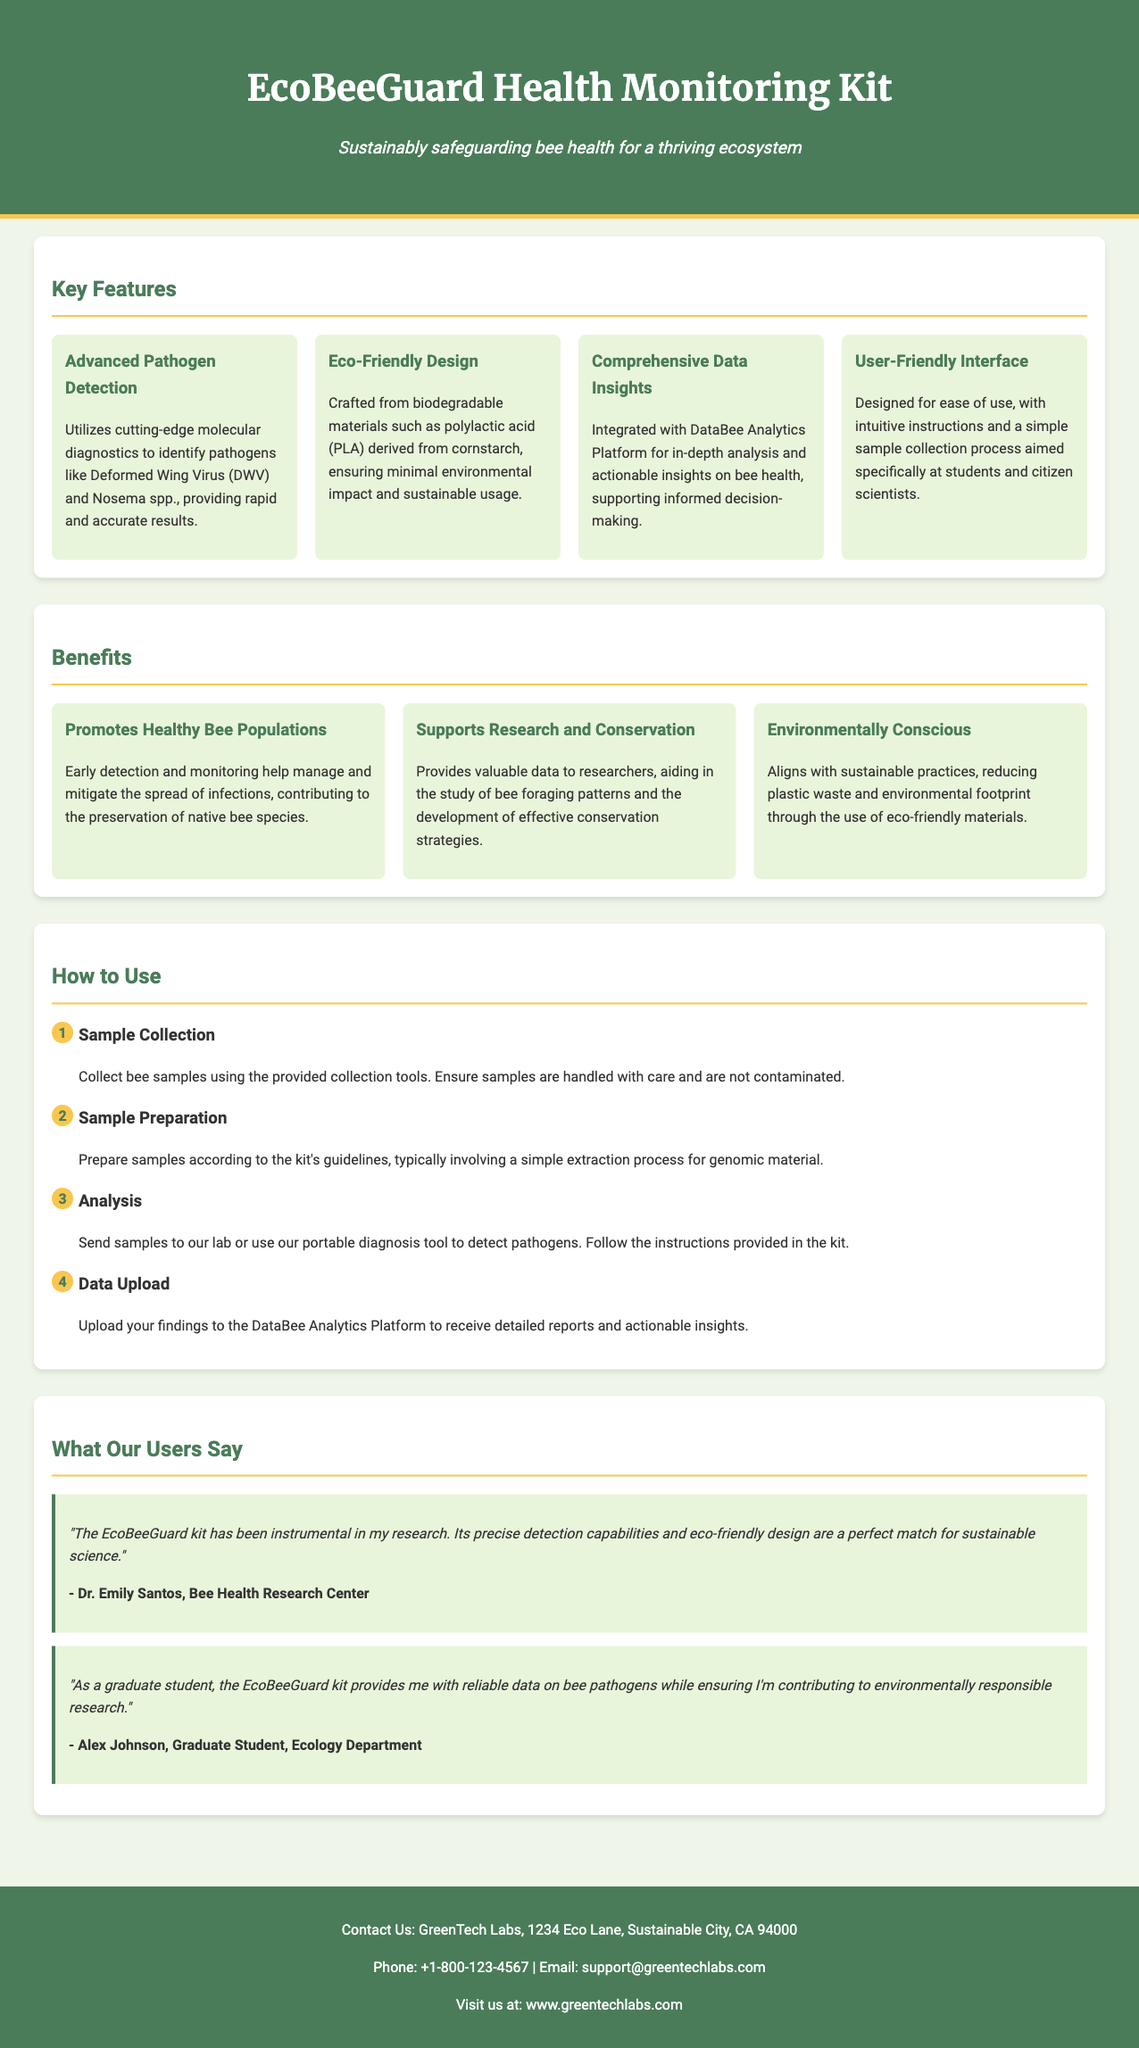What is the product name? The product name is stated prominently at the top of the document in the header.
Answer: EcoBeeGuard Health Monitoring Kit What pathogen is specifically detected by this kit? The pathogens detected are mentioned in the Key Features section.
Answer: Deformed Wing Virus (DWV) What type of materials is the wrapper made from? The materials used are noted in the Eco-Friendly Design feature.
Answer: Biodegradable materials How many steps are in the usage instruction section? The number of steps can be counted from the usage section.
Answer: Four Which platform provides data insights according to the document? The platform mentioned for data insights is described in the Comprehensive Data Insights feature.
Answer: DataBee Analytics Platform What is the main benefit of early detection according to the document? The primary benefit of early detection is highlighted in the Benefits section.
Answer: Promotes Healthy Bee Populations Who was quoted in the testimonials section? The testimonials include quotes from users, identified at the end of the section.
Answer: Dr. Emily Santos and Alex Johnson What is the contact email listed in the footer? The email for contact is provided at the bottom of the document in the footer.
Answer: support@greentechlabs.com How many testimonials are provided in the document? The testimonials can be counted in the What Our Users Say section.
Answer: Two 